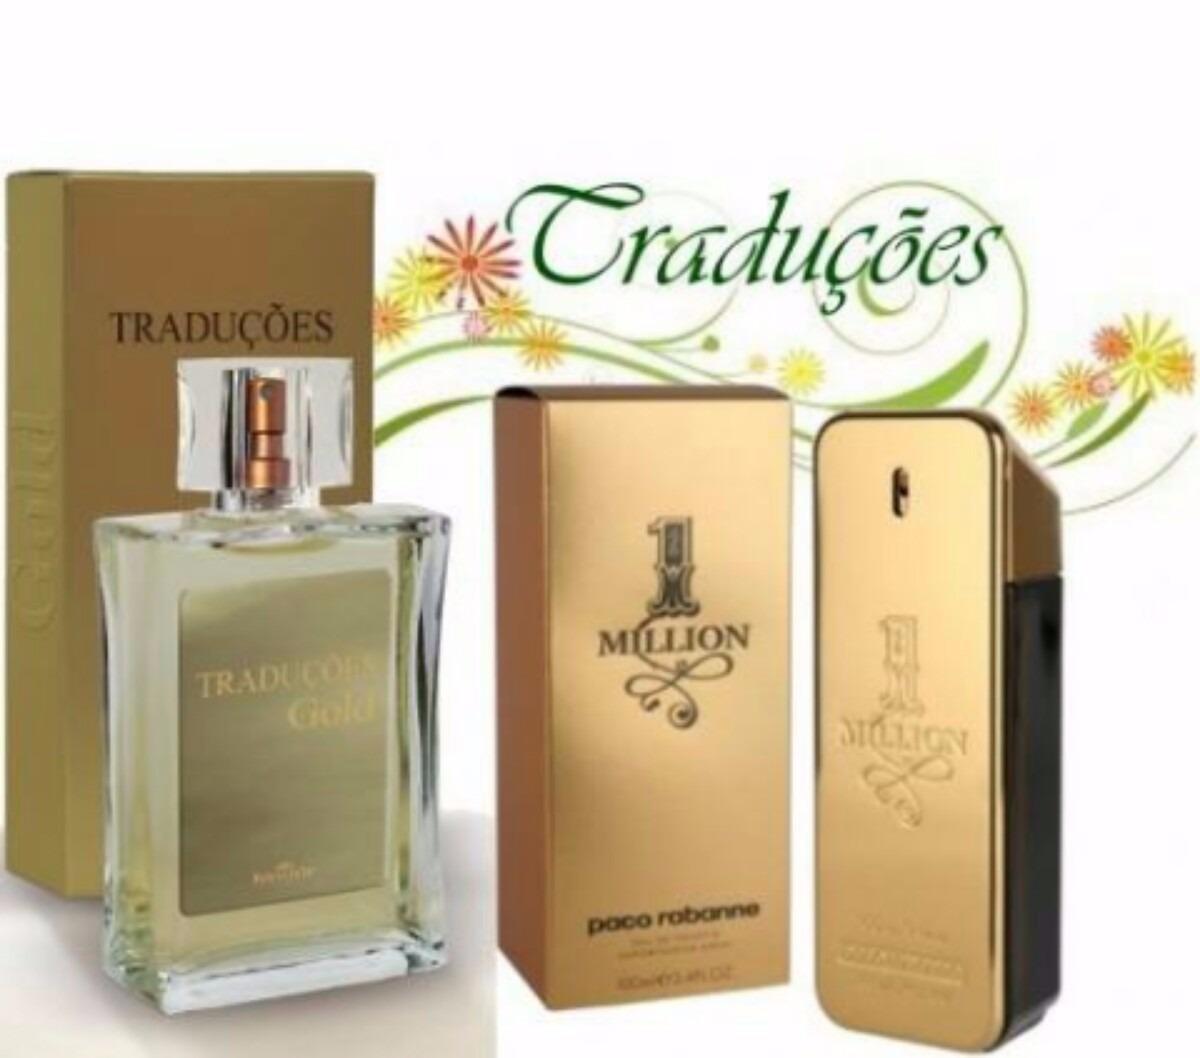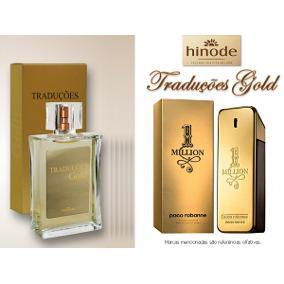The first image is the image on the left, the second image is the image on the right. For the images shown, is this caption "Each image shows two cologne products, at least one of which is a bottle of yellowish liquid with a square lid." true? Answer yes or no. Yes. The first image is the image on the left, the second image is the image on the right. Evaluate the accuracy of this statement regarding the images: "An image shows one square-bottled fragrance on the right side of its gold box, and not overlapping the box.". Is it true? Answer yes or no. No. 